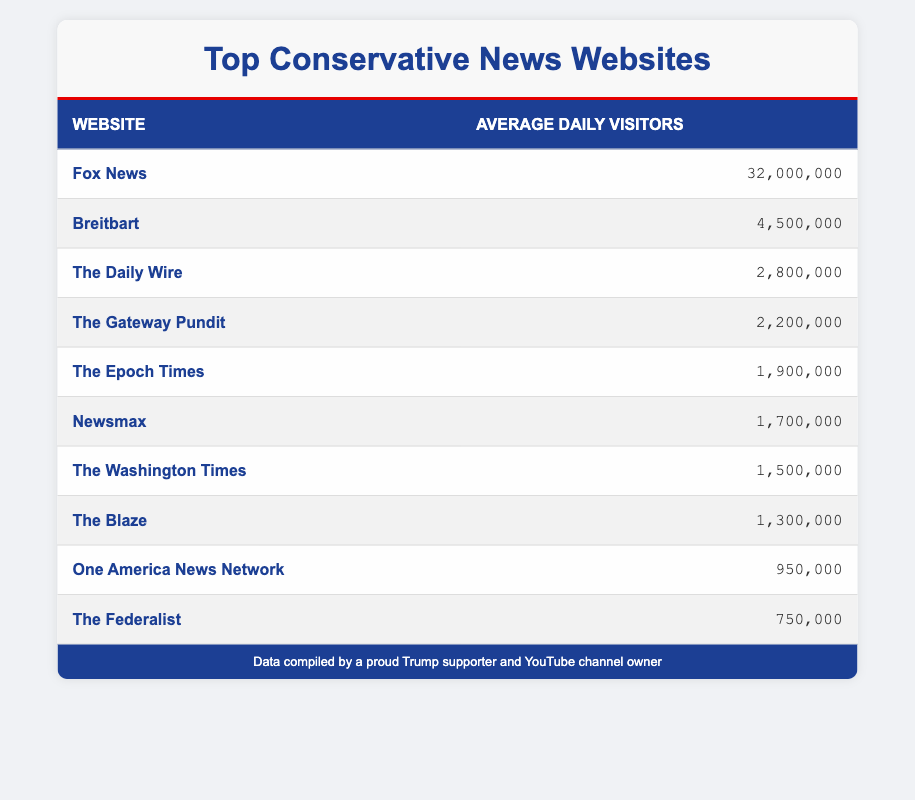What is the website with the highest average daily visitors? Looking at the first row of the table, Fox News is listed with 32,000,000 average daily visitors, which is higher than any other website in the table.
Answer: Fox News How many average daily visitors does The Daily Wire have? The Daily Wire is found in the table, specifically in the third row, showing it has 2,800,000 average daily visitors.
Answer: 2,800,000 Is the average daily visitor count of Newsmax greater than 1,000,000? Newsmax has 1,700,000 average daily visitors, which is indeed greater than 1,000,000.
Answer: Yes What is the total average daily visitors for the top three websites? The top three websites have the following visitors: Fox News (32,000,000), Breitbart (4,500,000), and The Daily Wire (2,800,000). Adding these together gives: 32,000,000 + 4,500,000 + 2,800,000 = 39,300,000.
Answer: 39,300,000 Which website is closest in average daily visitors to The Federalist? The Federalist has 750,000 average daily visitors. The next nearest in count is One America News Network with 950,000, only 200,000 more. The differences to other sites are larger.
Answer: One America News Network How many websites have more than 2,000,000 average daily visitors? By examining the table, the following websites exceed 2,000,000 daily visitors: Fox News, Breitbart, and The Daily Wire. That totals three websites.
Answer: 3 What is the average number of daily visitors for all websites listed? To find the average, first sum all the visitors: 32,000,000 + 4,500,000 + 2,800,000 + 2,200,000 + 1,900,000 + 1,700,000 + 1,500,000 + 1,300,000 + 950,000 + 750,000 = 49,850,000. There are 10 websites in total, so compute the average by dividing: 49,850,000 / 10 = 4,985,000.
Answer: 4,985,000 Is The Gateway Pundit among the top five websites based on average daily visitors? The Gateway Pundit has 2,200,000 visitors, which puts it in the fifth position when ranked by visitor count, thus confirming it is within the top five.
Answer: Yes What is the difference in average daily visitors between Fox News and The Blaze? Fox News has 32,000,000 visitors and The Blaze has 1,300,000 visitors. The difference can be found by subtracting: 32,000,000 - 1,300,000 = 30,700,000.
Answer: 30,700,000 